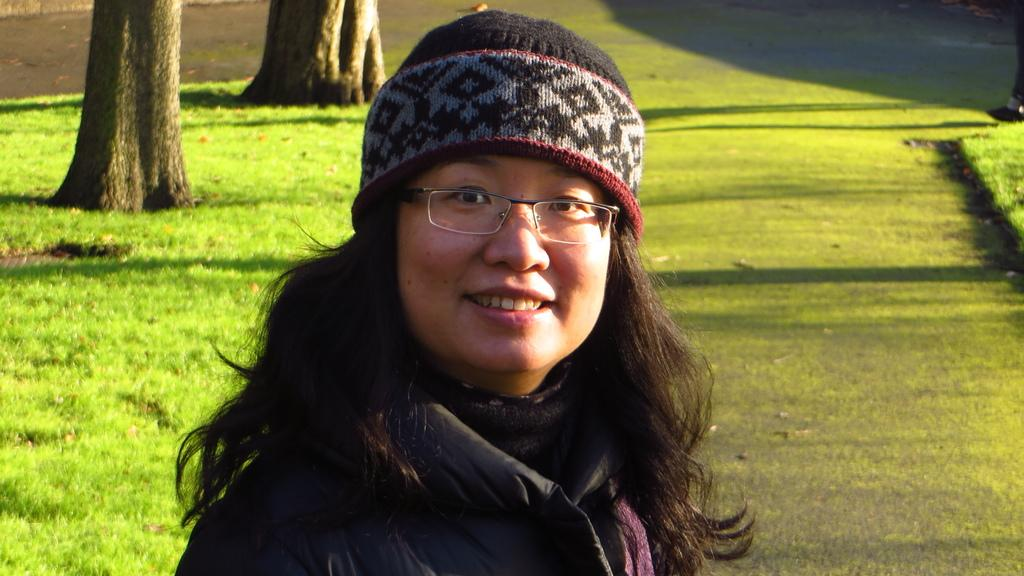What is the woman wearing in the image? The woman in the image is wearing spectacles. Where is the woman located in the image? The woman is standing in a park. What type of vegetation can be seen in the image? There are two big trees and green grass in the image. What object is present on the surface in the image? There is an object on the surface in the image, but its specific nature is not mentioned in the facts. Can you tell me how many dogs are playing with the woman in the image? There is no dog present in the image; the woman is standing in a park with trees and green grass. 